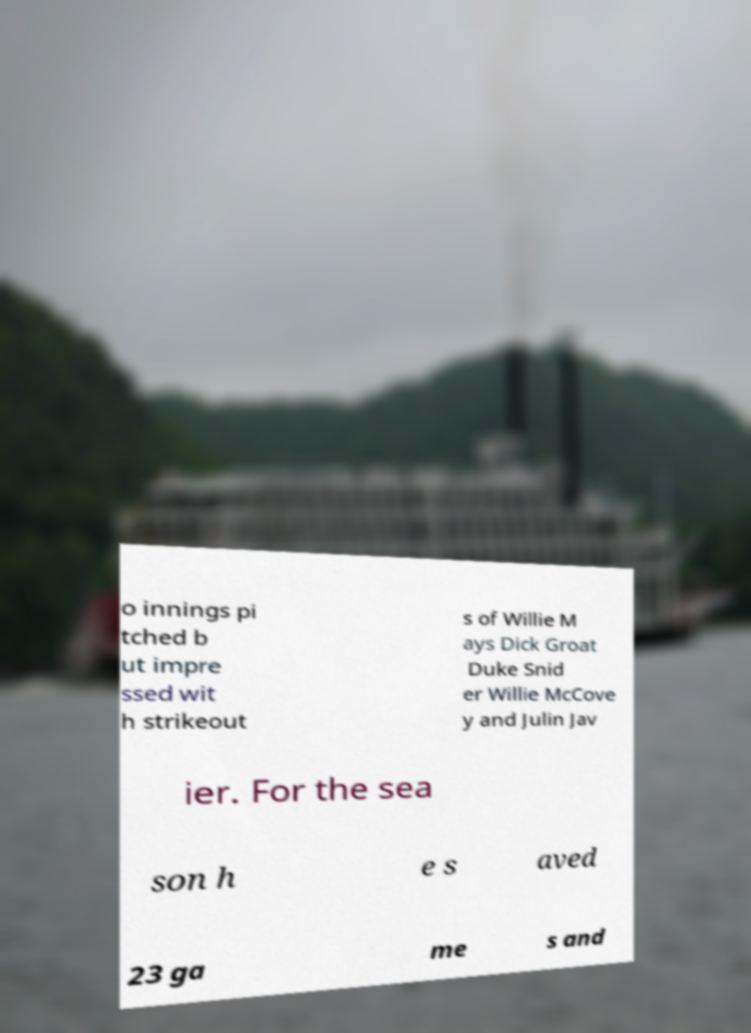Can you accurately transcribe the text from the provided image for me? o innings pi tched b ut impre ssed wit h strikeout s of Willie M ays Dick Groat Duke Snid er Willie McCove y and Julin Jav ier. For the sea son h e s aved 23 ga me s and 